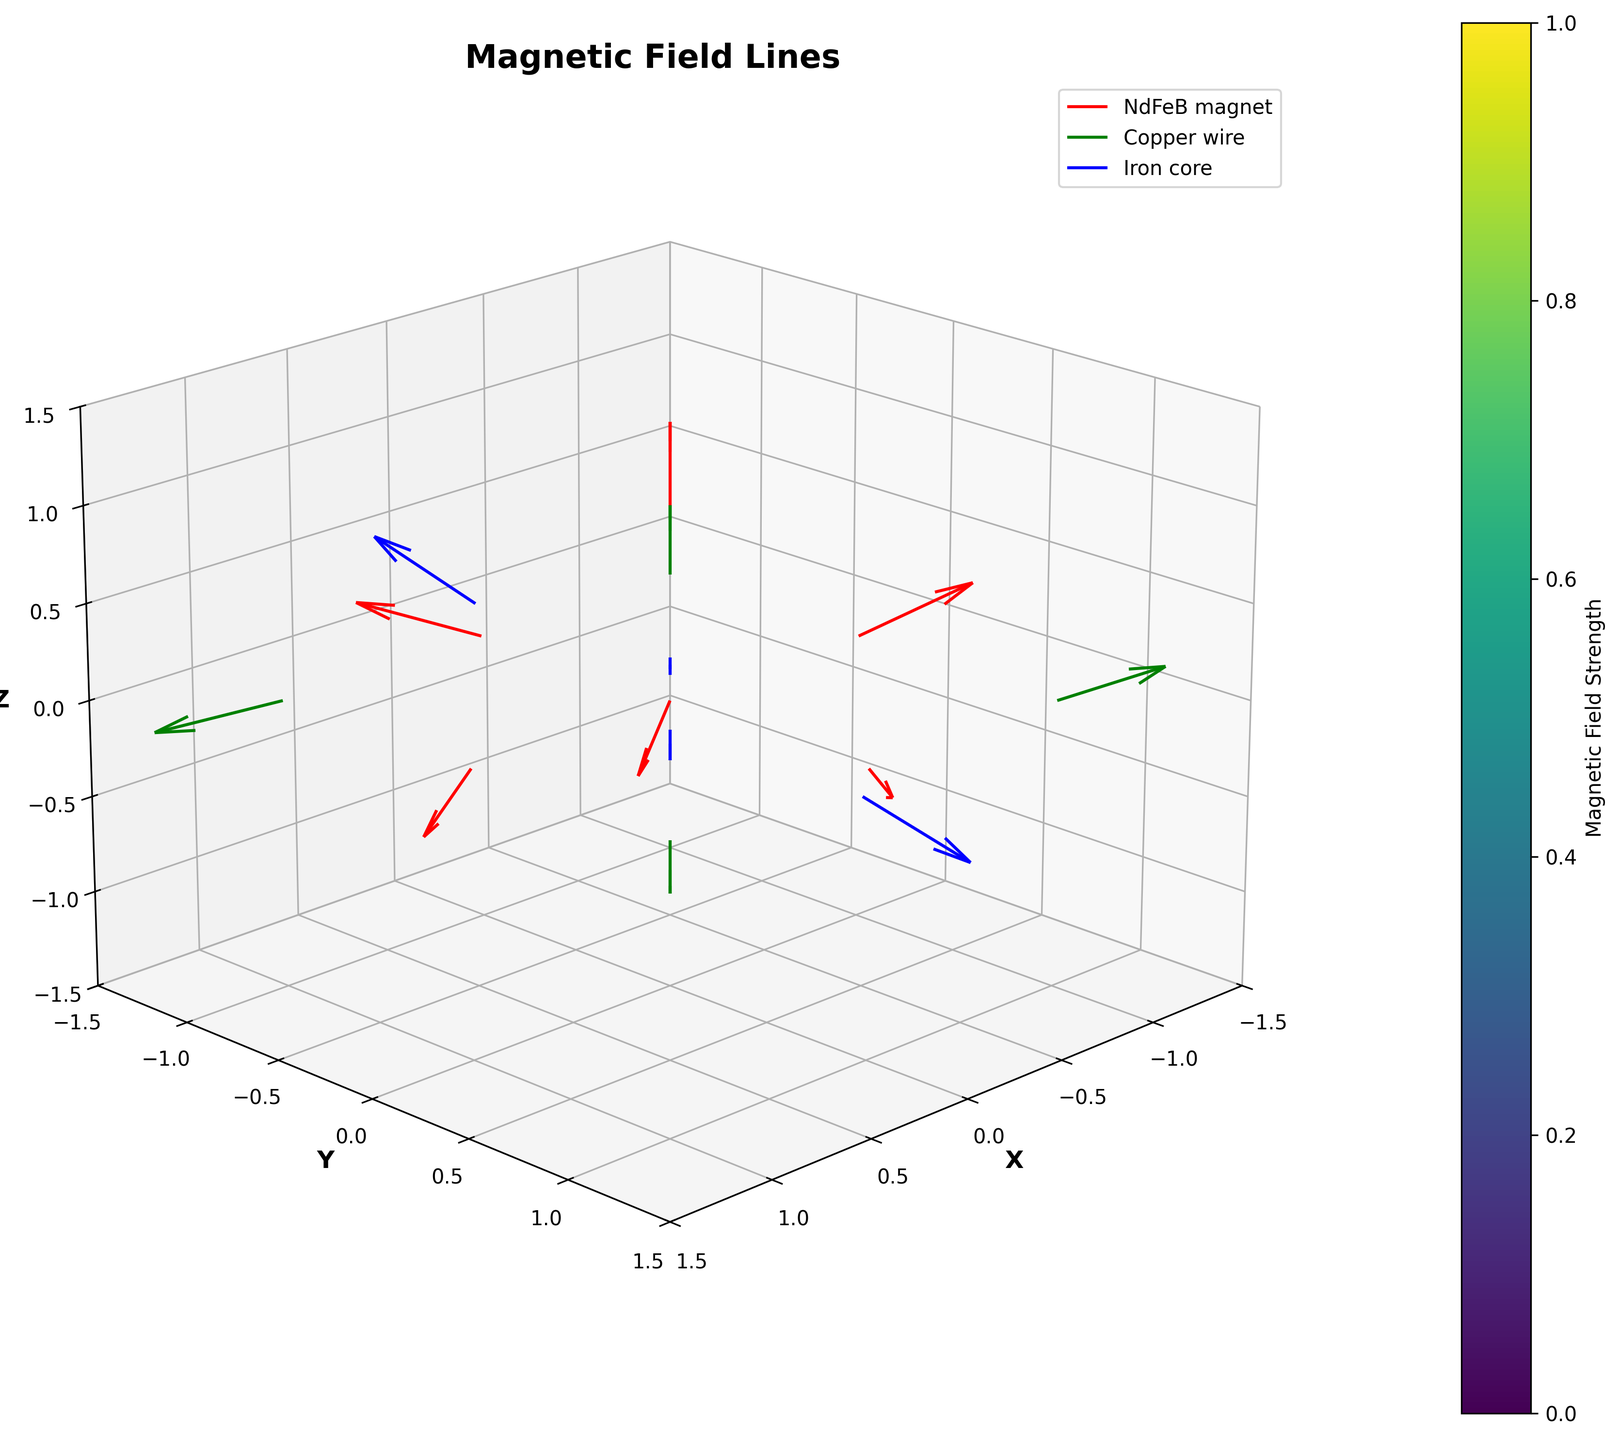What are the three components represented in the plot? The legend indicates the plot contains three components: NdFeB magnet, Copper wire, and Iron core.
Answer: NdFeB magnet, Copper wire, Iron core What is the title of the plot? The title is located at the top of the plot and reads "Magnetic Field Lines."
Answer: Magnetic Field Lines Which axis has the label 'Y'? The label for the 'Y' axis is visible on the vertical axis of the plot.
Answer: Y What color represents the magnetic field lines of the NdFeB magnets? The legend shows that the magnetic field lines for the NdFeB magnets are represented in red.
Answer: Red Which component has magnetic field lines at point (0,1,0)? By looking at the coordinates and the corresponding component, point (0,1,0) is associated with an NdFeB magnet.
Answer: NdFeB magnet How many magnetic field lines are associated with the Copper wire? By examining the plot and counting the green field lines, the Copper wire component has 4 magnetic field lines.
Answer: 4 Is there a specific axes limit set in the plot? If so, what are the limits for the Z-axis? The plot has set limits, visible on the axes. The Z-axis ranges from -1.5 to 1.5.
Answer: -1.5 to 1.5 Among the Copper wire components, which one shows the strongest magnetic field along the Z-axis? By comparing the Z components of the Copper wire magnetic fields, the point at (-1, 1, 0) with a value of 0.2 is the strongest.
Answer: (-1, 1, 0) What is the direction of the magnetic field line at point (0.5,0.5,0.5) for the Iron core component? The vector components at (0.5, 0.5, 0.5) indicate the field line points approximately in the (0.4, 0.4, 0.3) direction.
Answer: (0.4, 0.4, 0.3) Compare the direction of the magnetic field lines for NdFeB magnet at points (0,0,1) and (0,-1,0). Which one points more towards the Z direction? The magnetic field line at (0, 0, 1) has a Z-component of 0.5, whereas the field line at (0, -1, 0) has a Z-component of 0.1. So, (0, 0, 1) points more towards the Z direction.
Answer: (0,0,1) 